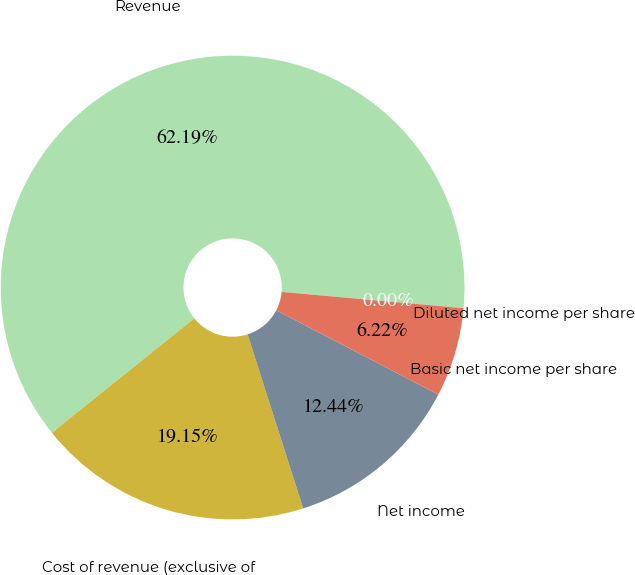Convert chart. <chart><loc_0><loc_0><loc_500><loc_500><pie_chart><fcel>Revenue<fcel>Cost of revenue (exclusive of<fcel>Net income<fcel>Basic net income per share<fcel>Diluted net income per share<nl><fcel>62.19%<fcel>19.15%<fcel>12.44%<fcel>6.22%<fcel>0.0%<nl></chart> 